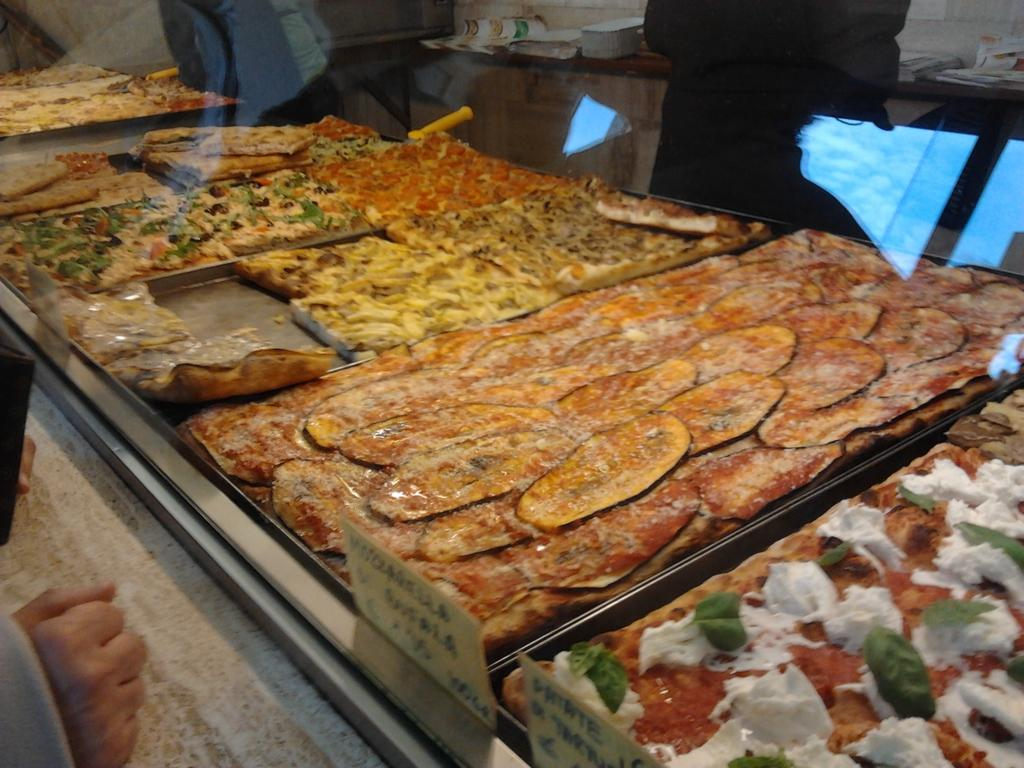What is present in the image that represents something edible? There is food in the image. Can you describe the colors of the food in the image? The food has colors including brown, yellow, and red. What part of a human body is visible in the image? A human hand is visible in the image. Are there any children playing with the produce in the image? There is no mention of children or produce in the image; it only features food and a human hand. What type of stew is being prepared in the image? There is no indication of any stew being prepared in the image. 